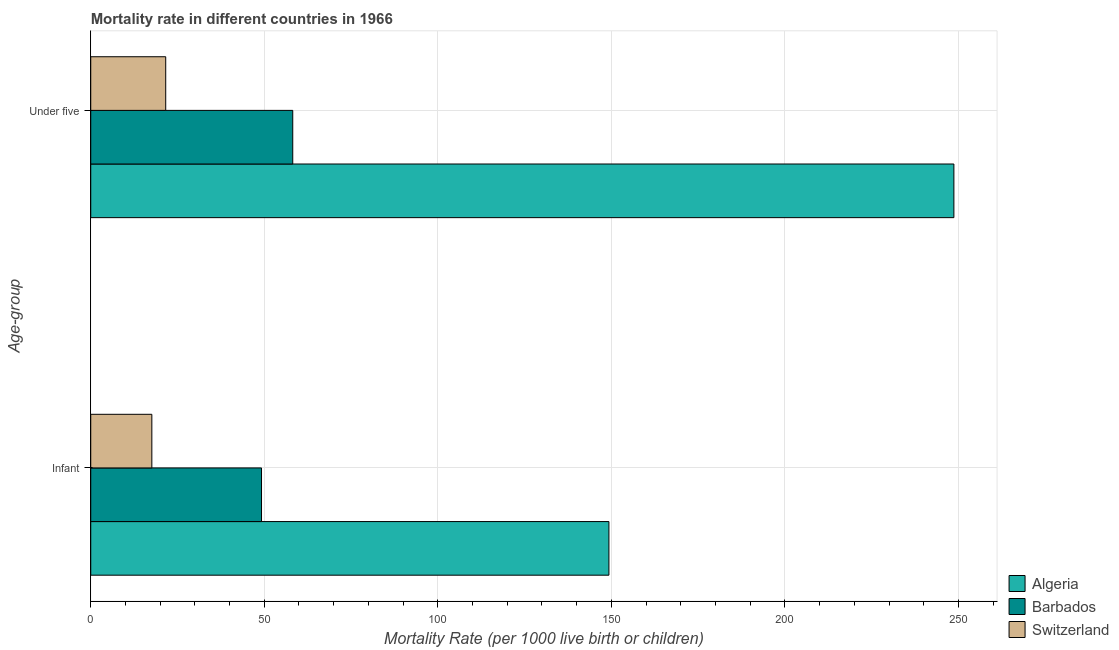How many different coloured bars are there?
Provide a succinct answer. 3. Are the number of bars on each tick of the Y-axis equal?
Keep it short and to the point. Yes. How many bars are there on the 1st tick from the top?
Keep it short and to the point. 3. How many bars are there on the 2nd tick from the bottom?
Ensure brevity in your answer.  3. What is the label of the 2nd group of bars from the top?
Your answer should be compact. Infant. What is the under-5 mortality rate in Barbados?
Provide a succinct answer. 58.2. Across all countries, what is the maximum under-5 mortality rate?
Provide a succinct answer. 248.7. Across all countries, what is the minimum under-5 mortality rate?
Make the answer very short. 21.6. In which country was the infant mortality rate maximum?
Ensure brevity in your answer.  Algeria. In which country was the under-5 mortality rate minimum?
Provide a short and direct response. Switzerland. What is the total infant mortality rate in the graph?
Offer a very short reply. 216.1. What is the difference between the under-5 mortality rate in Barbados and that in Switzerland?
Keep it short and to the point. 36.6. What is the difference between the under-5 mortality rate in Barbados and the infant mortality rate in Algeria?
Provide a short and direct response. -91.1. What is the average infant mortality rate per country?
Provide a short and direct response. 72.03. What is the difference between the infant mortality rate and under-5 mortality rate in Barbados?
Provide a short and direct response. -9. In how many countries, is the infant mortality rate greater than 200 ?
Give a very brief answer. 0. What is the ratio of the under-5 mortality rate in Barbados to that in Switzerland?
Offer a terse response. 2.69. What does the 1st bar from the top in Under five represents?
Provide a succinct answer. Switzerland. What does the 3rd bar from the bottom in Infant represents?
Your answer should be very brief. Switzerland. How many bars are there?
Your answer should be compact. 6. How many countries are there in the graph?
Your response must be concise. 3. Does the graph contain any zero values?
Keep it short and to the point. No. Does the graph contain grids?
Your answer should be compact. Yes. How are the legend labels stacked?
Your answer should be very brief. Vertical. What is the title of the graph?
Your answer should be compact. Mortality rate in different countries in 1966. Does "Tajikistan" appear as one of the legend labels in the graph?
Ensure brevity in your answer.  No. What is the label or title of the X-axis?
Provide a short and direct response. Mortality Rate (per 1000 live birth or children). What is the label or title of the Y-axis?
Make the answer very short. Age-group. What is the Mortality Rate (per 1000 live birth or children) in Algeria in Infant?
Ensure brevity in your answer.  149.3. What is the Mortality Rate (per 1000 live birth or children) in Barbados in Infant?
Give a very brief answer. 49.2. What is the Mortality Rate (per 1000 live birth or children) of Algeria in Under five?
Your response must be concise. 248.7. What is the Mortality Rate (per 1000 live birth or children) in Barbados in Under five?
Keep it short and to the point. 58.2. What is the Mortality Rate (per 1000 live birth or children) of Switzerland in Under five?
Your answer should be very brief. 21.6. Across all Age-group, what is the maximum Mortality Rate (per 1000 live birth or children) in Algeria?
Provide a short and direct response. 248.7. Across all Age-group, what is the maximum Mortality Rate (per 1000 live birth or children) in Barbados?
Your answer should be compact. 58.2. Across all Age-group, what is the maximum Mortality Rate (per 1000 live birth or children) in Switzerland?
Offer a very short reply. 21.6. Across all Age-group, what is the minimum Mortality Rate (per 1000 live birth or children) in Algeria?
Your answer should be very brief. 149.3. Across all Age-group, what is the minimum Mortality Rate (per 1000 live birth or children) of Barbados?
Offer a terse response. 49.2. Across all Age-group, what is the minimum Mortality Rate (per 1000 live birth or children) in Switzerland?
Your answer should be compact. 17.6. What is the total Mortality Rate (per 1000 live birth or children) of Algeria in the graph?
Provide a succinct answer. 398. What is the total Mortality Rate (per 1000 live birth or children) in Barbados in the graph?
Your answer should be very brief. 107.4. What is the total Mortality Rate (per 1000 live birth or children) in Switzerland in the graph?
Your answer should be very brief. 39.2. What is the difference between the Mortality Rate (per 1000 live birth or children) of Algeria in Infant and that in Under five?
Offer a very short reply. -99.4. What is the difference between the Mortality Rate (per 1000 live birth or children) in Barbados in Infant and that in Under five?
Give a very brief answer. -9. What is the difference between the Mortality Rate (per 1000 live birth or children) in Algeria in Infant and the Mortality Rate (per 1000 live birth or children) in Barbados in Under five?
Provide a succinct answer. 91.1. What is the difference between the Mortality Rate (per 1000 live birth or children) of Algeria in Infant and the Mortality Rate (per 1000 live birth or children) of Switzerland in Under five?
Your response must be concise. 127.7. What is the difference between the Mortality Rate (per 1000 live birth or children) of Barbados in Infant and the Mortality Rate (per 1000 live birth or children) of Switzerland in Under five?
Provide a succinct answer. 27.6. What is the average Mortality Rate (per 1000 live birth or children) of Algeria per Age-group?
Offer a very short reply. 199. What is the average Mortality Rate (per 1000 live birth or children) in Barbados per Age-group?
Provide a short and direct response. 53.7. What is the average Mortality Rate (per 1000 live birth or children) in Switzerland per Age-group?
Keep it short and to the point. 19.6. What is the difference between the Mortality Rate (per 1000 live birth or children) in Algeria and Mortality Rate (per 1000 live birth or children) in Barbados in Infant?
Provide a short and direct response. 100.1. What is the difference between the Mortality Rate (per 1000 live birth or children) of Algeria and Mortality Rate (per 1000 live birth or children) of Switzerland in Infant?
Your answer should be compact. 131.7. What is the difference between the Mortality Rate (per 1000 live birth or children) of Barbados and Mortality Rate (per 1000 live birth or children) of Switzerland in Infant?
Provide a short and direct response. 31.6. What is the difference between the Mortality Rate (per 1000 live birth or children) of Algeria and Mortality Rate (per 1000 live birth or children) of Barbados in Under five?
Your response must be concise. 190.5. What is the difference between the Mortality Rate (per 1000 live birth or children) of Algeria and Mortality Rate (per 1000 live birth or children) of Switzerland in Under five?
Your answer should be compact. 227.1. What is the difference between the Mortality Rate (per 1000 live birth or children) of Barbados and Mortality Rate (per 1000 live birth or children) of Switzerland in Under five?
Your answer should be compact. 36.6. What is the ratio of the Mortality Rate (per 1000 live birth or children) of Algeria in Infant to that in Under five?
Offer a very short reply. 0.6. What is the ratio of the Mortality Rate (per 1000 live birth or children) in Barbados in Infant to that in Under five?
Keep it short and to the point. 0.85. What is the ratio of the Mortality Rate (per 1000 live birth or children) in Switzerland in Infant to that in Under five?
Provide a succinct answer. 0.81. What is the difference between the highest and the second highest Mortality Rate (per 1000 live birth or children) in Algeria?
Make the answer very short. 99.4. What is the difference between the highest and the lowest Mortality Rate (per 1000 live birth or children) in Algeria?
Your response must be concise. 99.4. What is the difference between the highest and the lowest Mortality Rate (per 1000 live birth or children) of Barbados?
Keep it short and to the point. 9. What is the difference between the highest and the lowest Mortality Rate (per 1000 live birth or children) of Switzerland?
Offer a terse response. 4. 